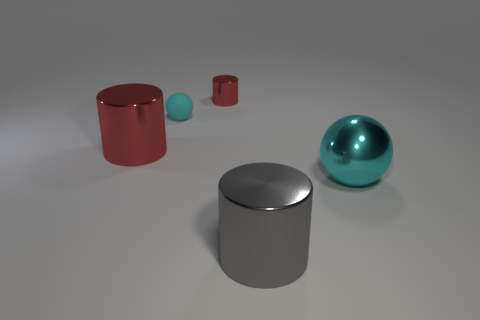Subtract all red metallic cylinders. How many cylinders are left? 1 Subtract 0 blue cubes. How many objects are left? 5 Subtract all cylinders. How many objects are left? 2 Subtract 1 cylinders. How many cylinders are left? 2 Subtract all yellow cylinders. Subtract all brown cubes. How many cylinders are left? 3 Subtract all cyan blocks. How many red cylinders are left? 2 Subtract all small cylinders. Subtract all large gray spheres. How many objects are left? 4 Add 3 tiny cyan rubber objects. How many tiny cyan rubber objects are left? 4 Add 2 red metal cylinders. How many red metal cylinders exist? 4 Add 4 big cyan balls. How many objects exist? 9 